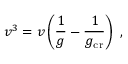Convert formula to latex. <formula><loc_0><loc_0><loc_500><loc_500>v ^ { 3 } = v \left ( \frac { 1 } { g } - \frac { 1 } { g _ { c r } } \right ) \ ,</formula> 